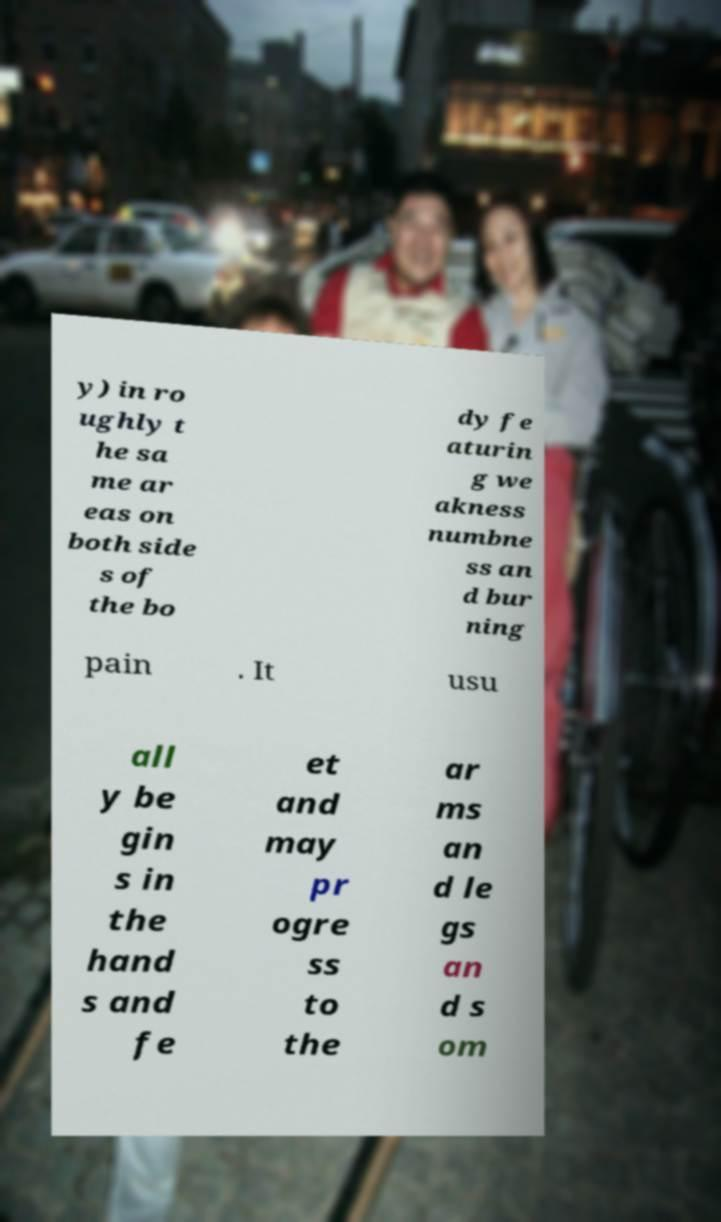For documentation purposes, I need the text within this image transcribed. Could you provide that? y) in ro ughly t he sa me ar eas on both side s of the bo dy fe aturin g we akness numbne ss an d bur ning pain . It usu all y be gin s in the hand s and fe et and may pr ogre ss to the ar ms an d le gs an d s om 